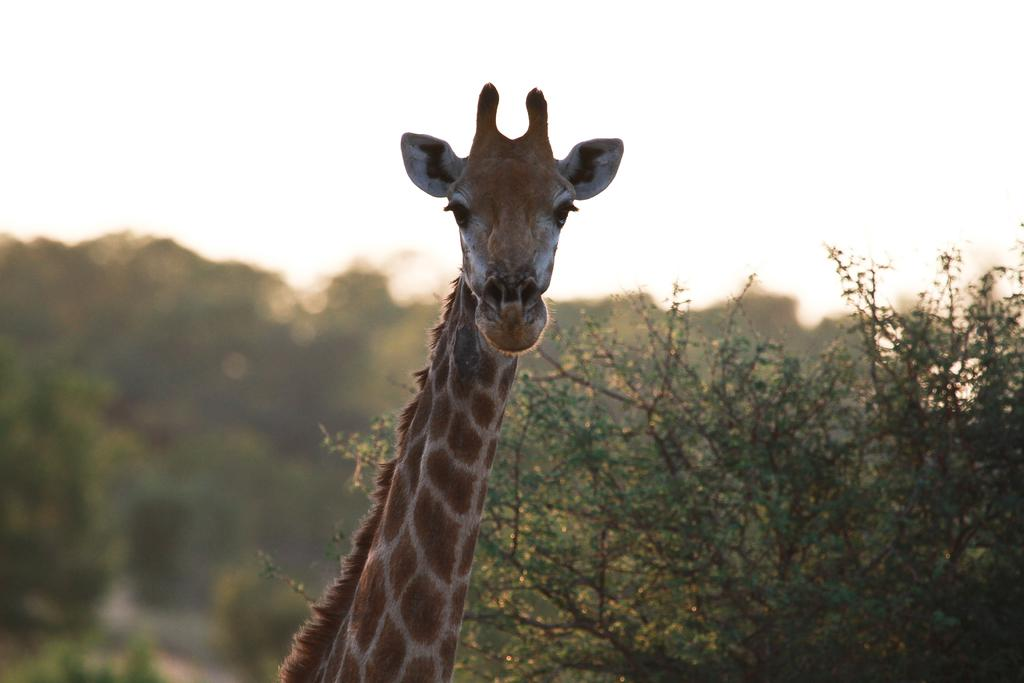What animal is the main subject of the picture? There is a giraffe in the picture. What is the color of the giraffe? The giraffe is brown in color. What is the giraffe doing in the picture? The giraffe is looking at the camera. What can be seen in the background of the picture? There are trees visible in the background of the picture. What type of lumber is being used to build the cars in the image? There are no cars or lumber present in the image; it features a brown giraffe looking at the camera with trees in the background. 